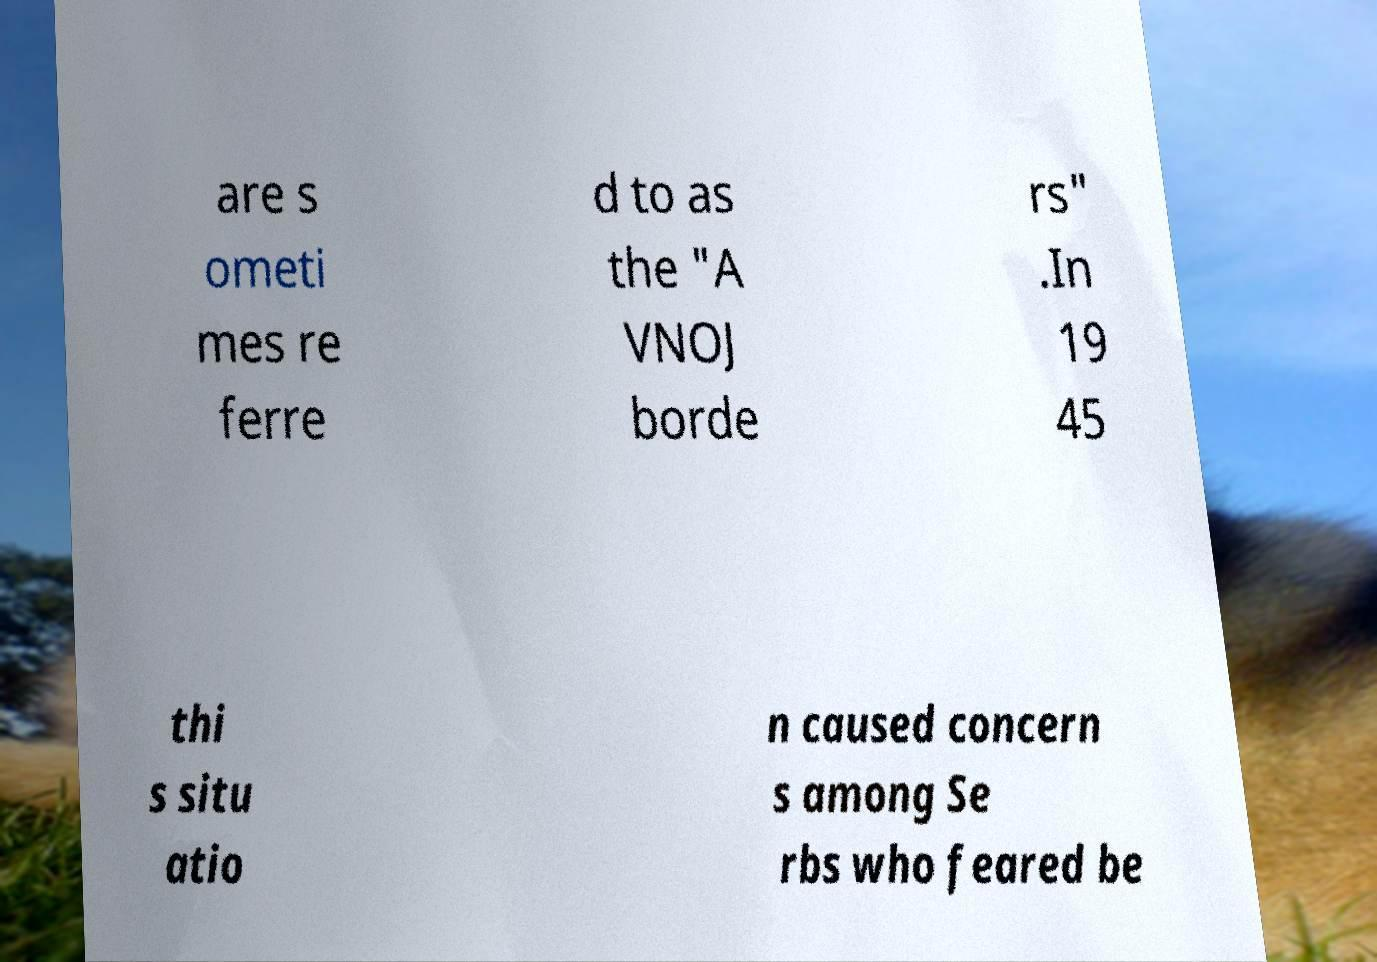Please read and relay the text visible in this image. What does it say? are s ometi mes re ferre d to as the "A VNOJ borde rs" .In 19 45 thi s situ atio n caused concern s among Se rbs who feared be 